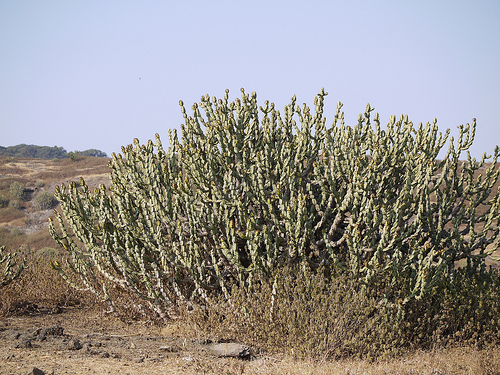<image>
Can you confirm if the bush is in the bush? No. The bush is not contained within the bush. These objects have a different spatial relationship. 